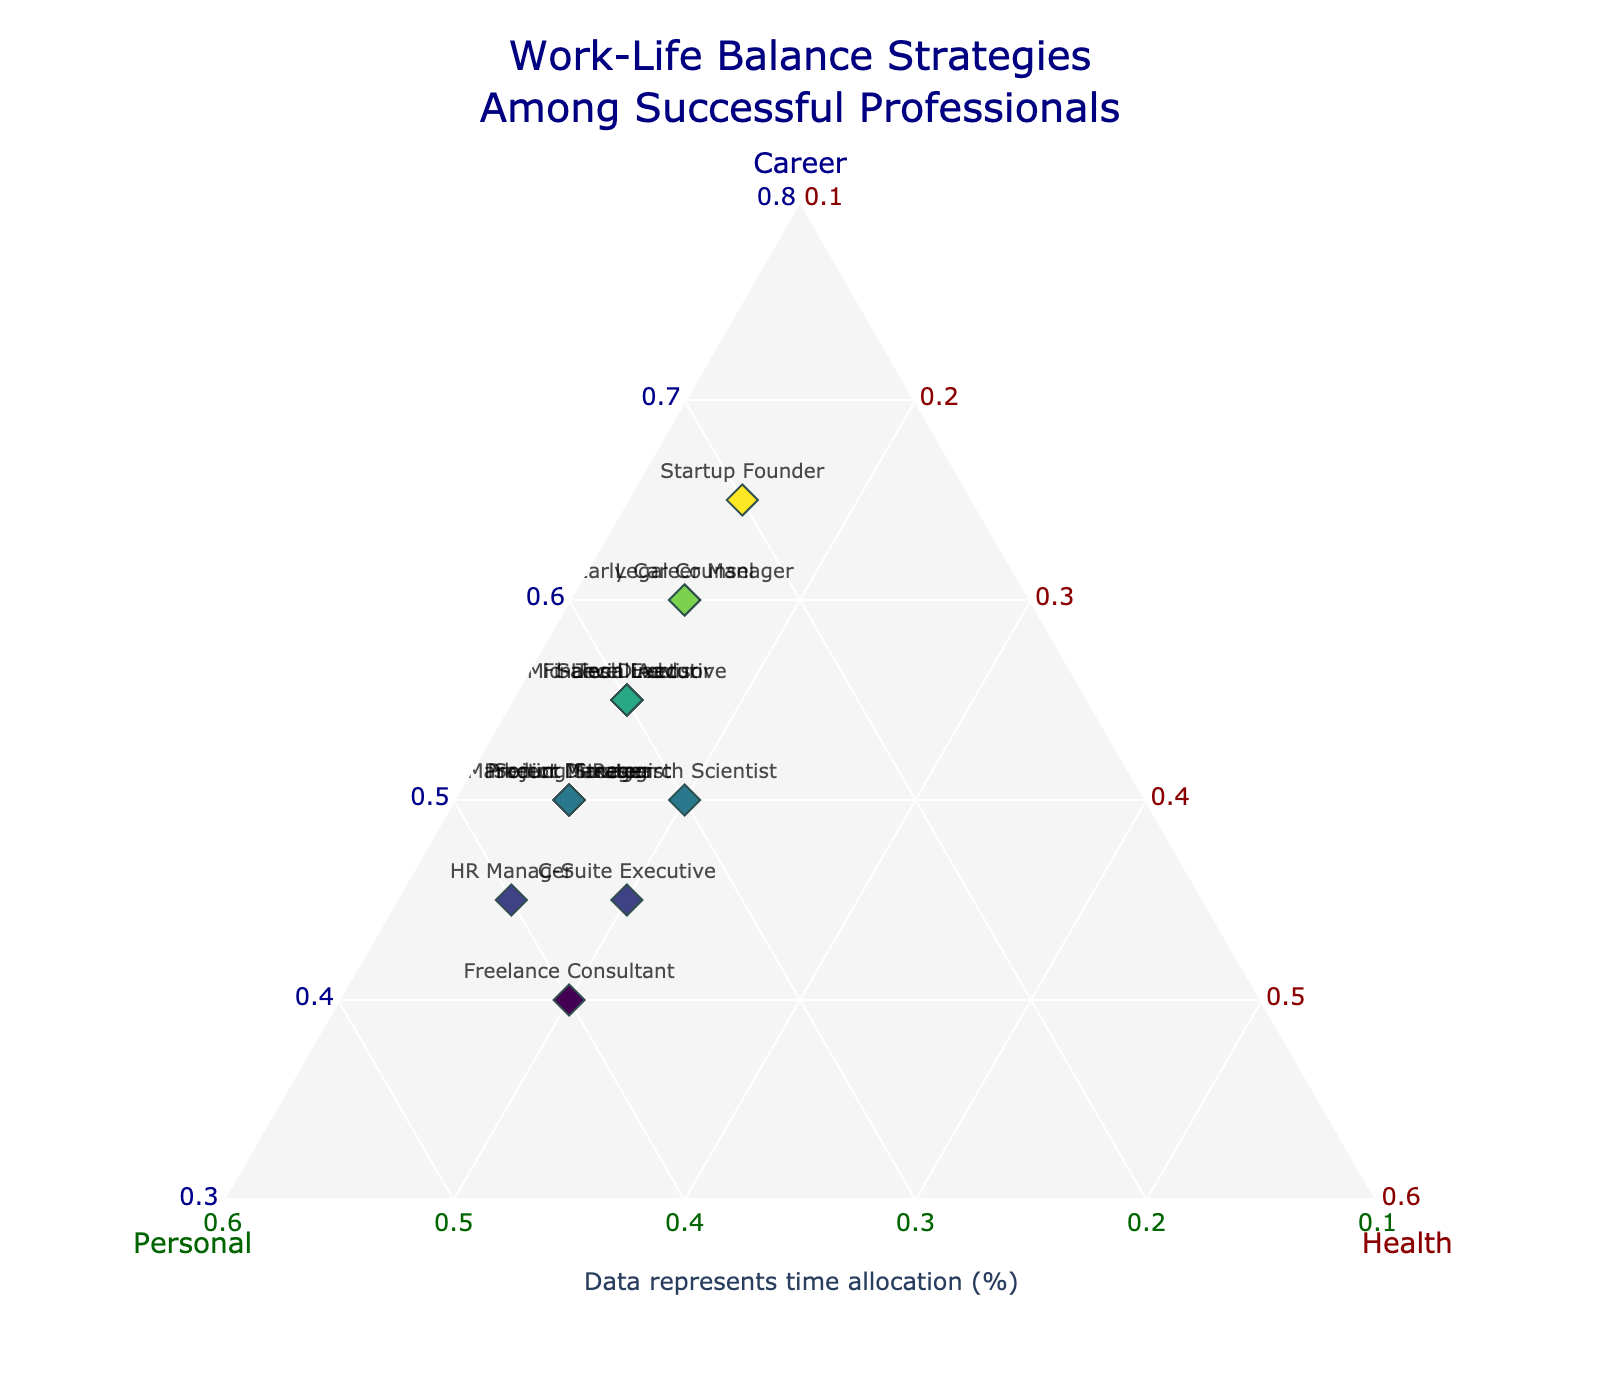How many professionals allocate more time to personal life compared to their health? To answer this question, identify professionals for whom the 'Personal' percentage is higher than the 'Health' percentage. By visual inspection: Mid-Level Executive (30% vs. 15%), Senior Director (35% vs. 15%), C-Suite Executive (35% vs. 20%), Tech Lead (30% vs. 15%), Project Manager (35% vs. 15%), HR Manager (40% vs. 15%), Marketing Strategist (35% vs. 15%), and Product Manager (35% vs. 15%).
Answer: 8 Which professional dedicates the lowest time percentage to personal life? Check the y-axis of the ternary plot to find the lowest personal time allocation. The 'Startup Founder' spends 20% on personal life, which is the lowest in the dataset.
Answer: Startup Founder What is the average percentage of time spent on health among the professionals shown? Sum all the percentages for 'Health': 15 + 15 + 15 + 20 + 15 + 20 + 15 + 15 + 15 + 15 + 20 + 15 + 15 + 15 + 15 = 240. There are 15 professionals, so the average is 240/15 = 16%.
Answer: 16% Which professional has the most balanced time allocation between the three categories? Balance means the three allocations are closest to one another. The 'Freelance Consultant' has allocations of 40% career, 40% personal, and 20% health, which is nearest to an even split.
Answer: Freelance Consultant Is there any professional whose time allocation to health exceeds 20%? Check the 'Health' axis for values surpassing 20%. All professionals have health time allocation less than or equal to 20%.
Answer: No What's the difference between time spent on career and personal life for a Tech Lead? From the figure, the Tech Lead spends 55% on career and 30% on personal life. The difference is 55% - 30% = 25%.
Answer: 25% How many professionals spend exactly 50% of their time on their career? From the plot, identify professionals spending 50% on their career: Senior Director, Project Manager, Research Scientist, Marketing Strategist, and Product Manager. There are five of them.
Answer: 5 Who spends the highest percentage of their time on health? Check the 'Health' axis, 'Freelance Consultant' and 'Research Scientist' have the highest health time allocation at 20%.
Answer: Freelance Consultant and Research Scientist 